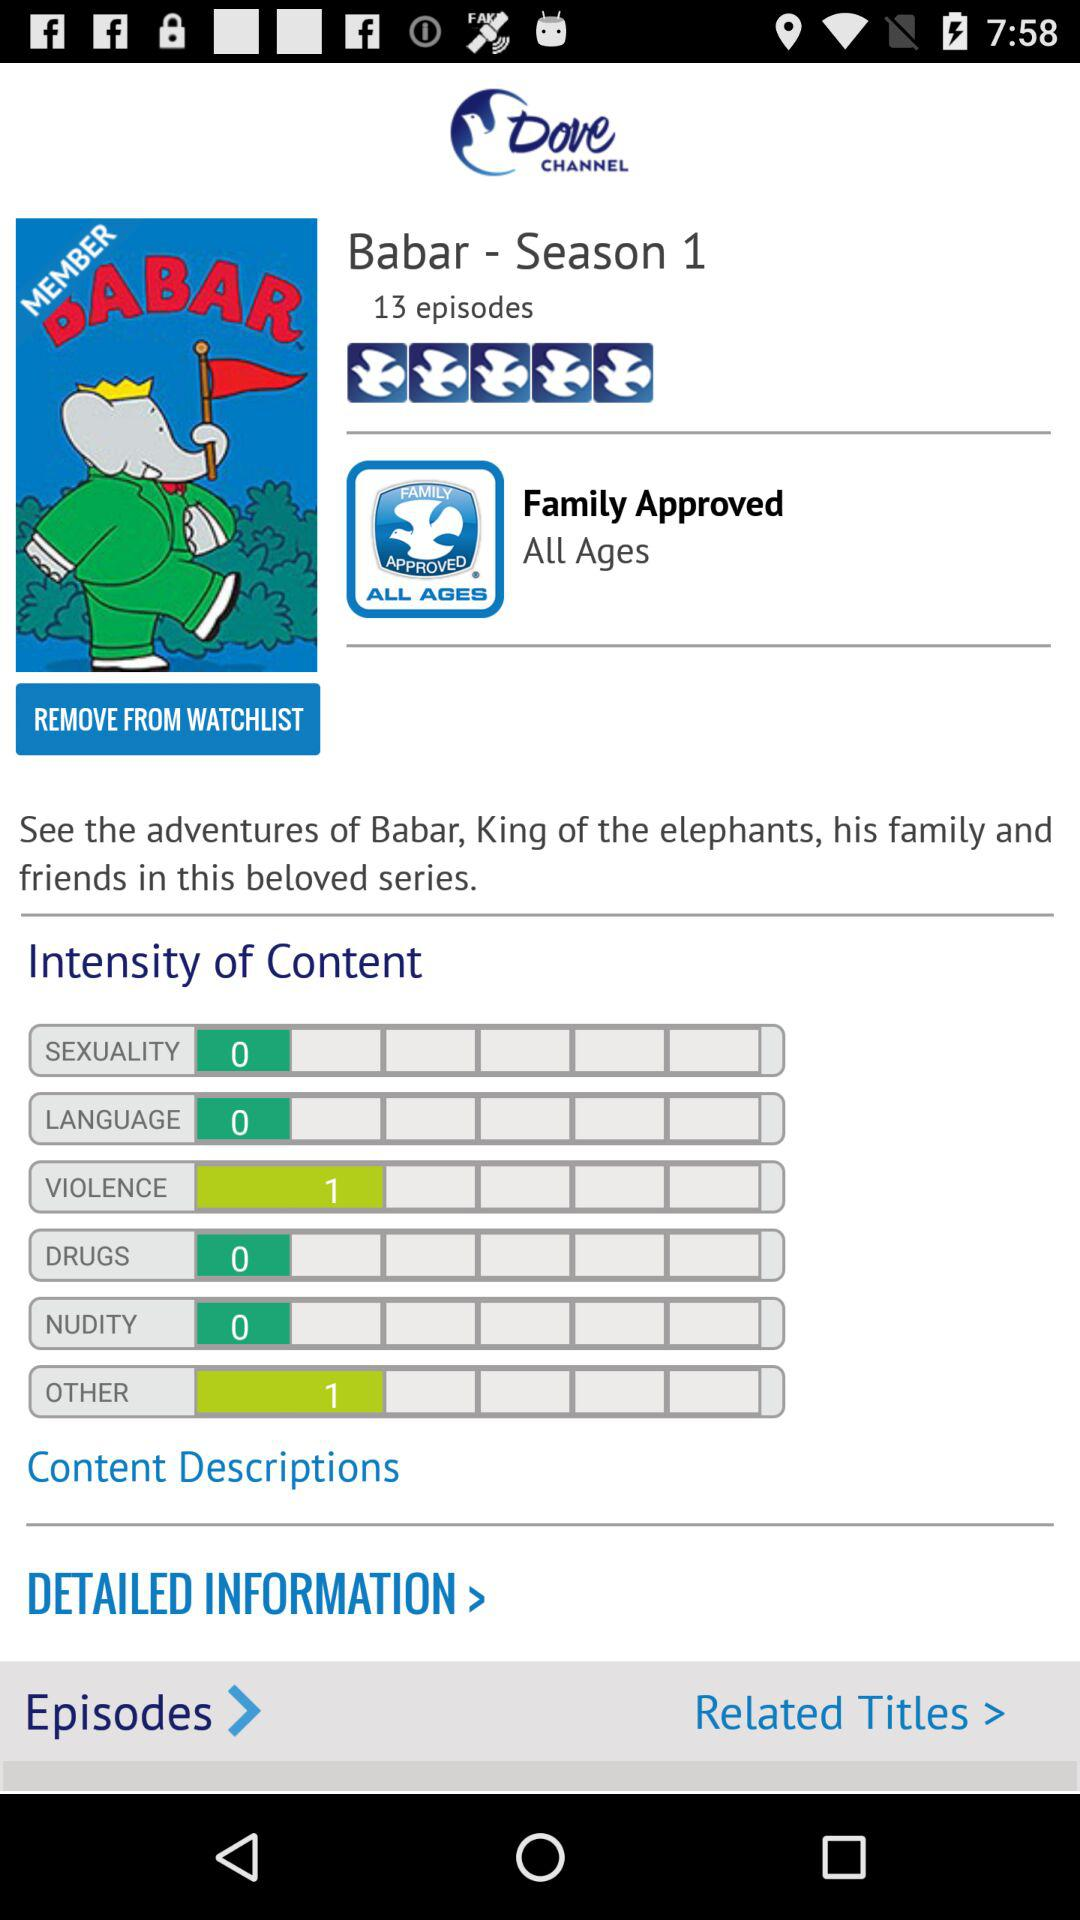How many episodes are there in Babar - Season 1?
Answer the question using a single word or phrase. 13 